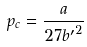Convert formula to latex. <formula><loc_0><loc_0><loc_500><loc_500>p _ { c } = \frac { a } { 2 7 { b ^ { \prime } } ^ { 2 } }</formula> 